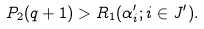Convert formula to latex. <formula><loc_0><loc_0><loc_500><loc_500>P _ { 2 } ( q + 1 ) > R _ { 1 } ( \alpha _ { i } ^ { \prime } ; i \in J ^ { \prime } ) .</formula> 